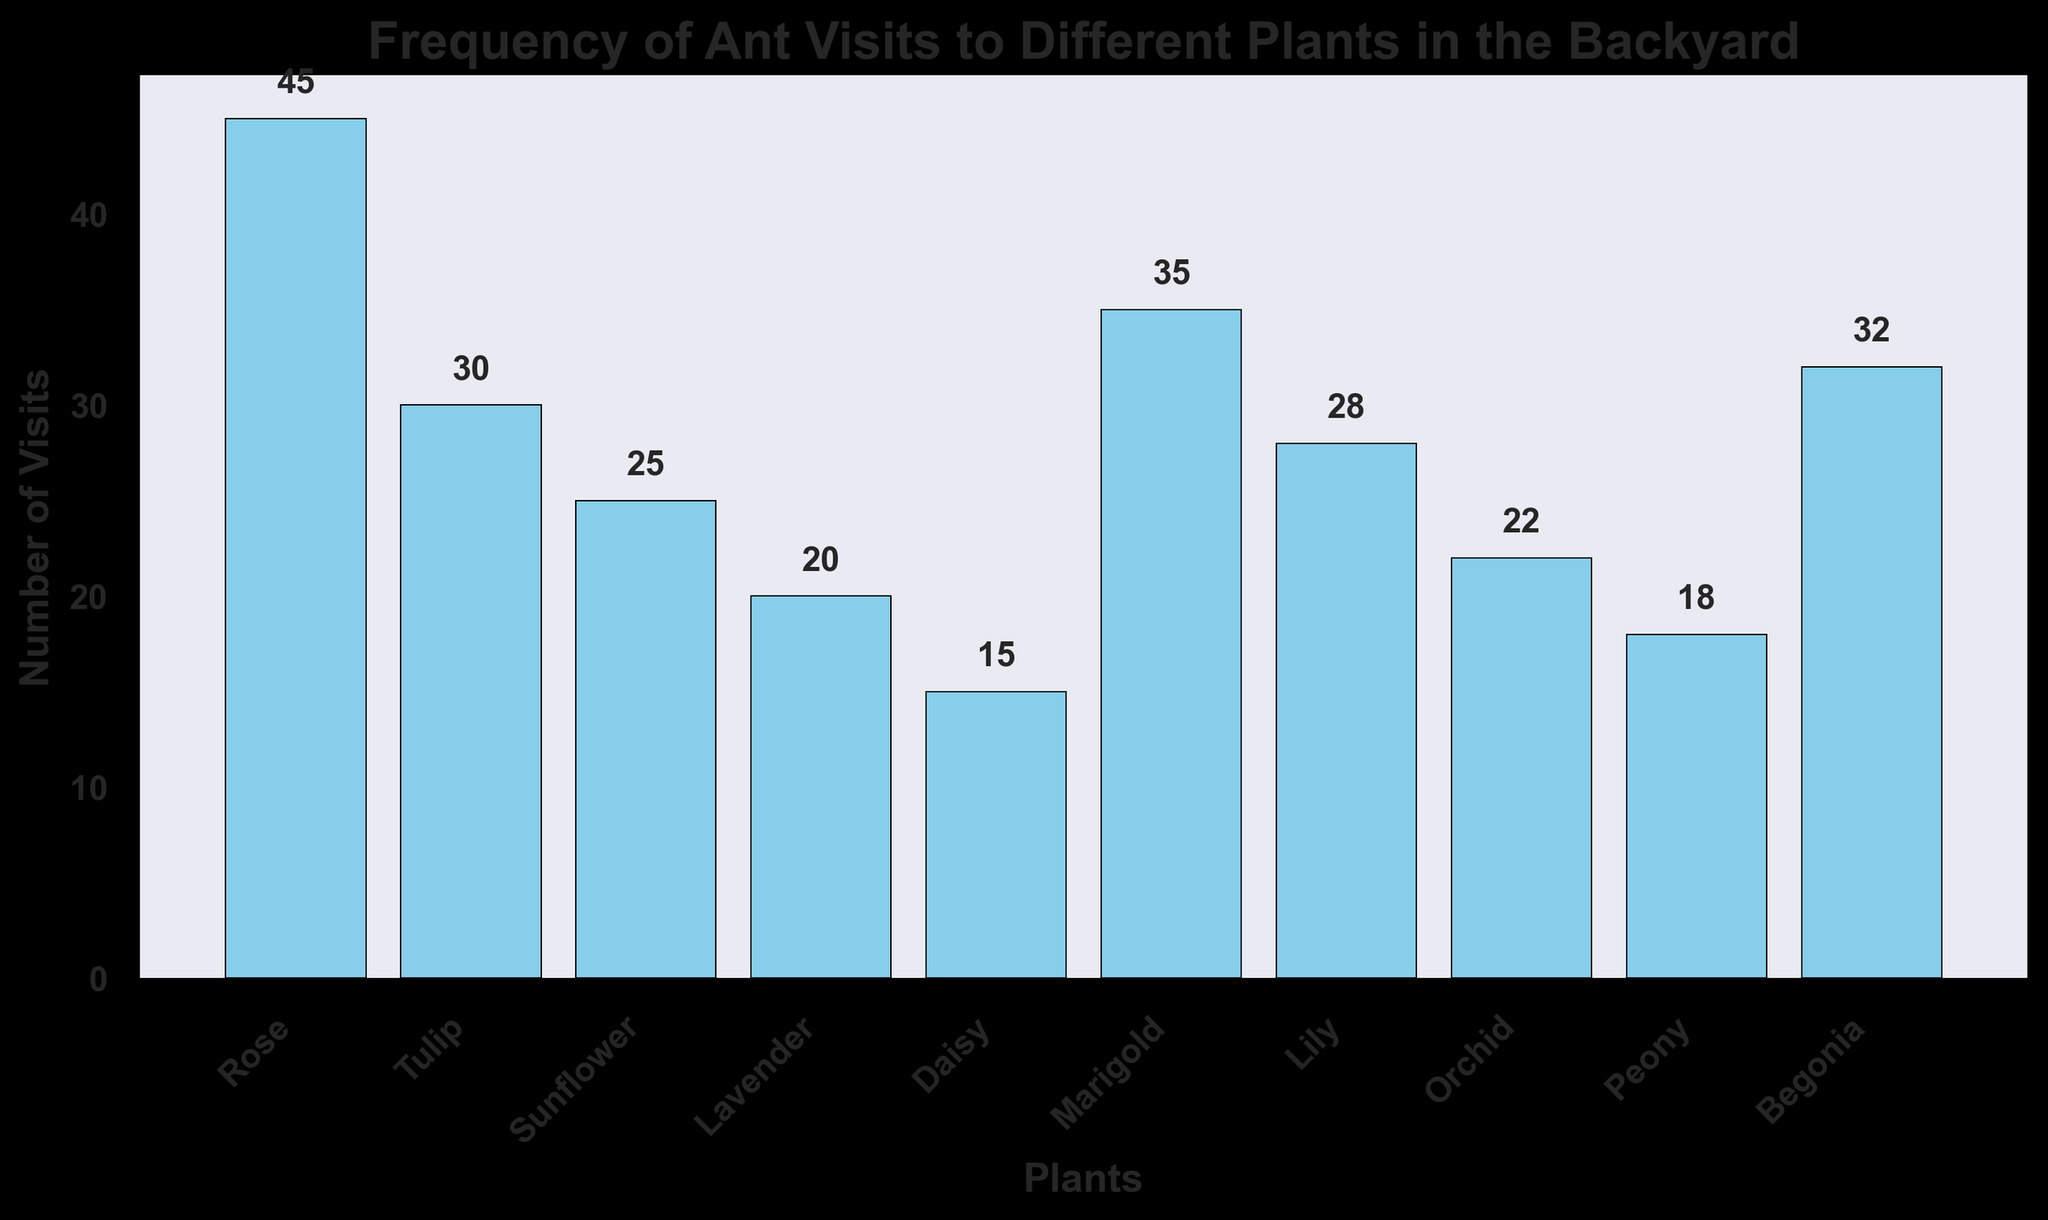Which plant had the highest number of ant visits? To determine this, look at the heights of the bars in the bar chart. The plant with the tallest bar represents the plant with the most visits. The Rose bar is the highest, indicating it had the most visits.
Answer: Rose Which two plants had the least number of ant visits? Look at the heights of the bars and find the two shortest ones. The Daisy bar, followed by the Lavender bar, are the shortest, thus these two plants had the fewest visits.
Answer: Daisy, Lavender What is the difference in the number of visits between the plant with the most visits and the plant with the least visits? First, identify the highest and lowest values from the bar chart. The most visits are 45 (Rose) and the least is 15 (Daisy). Subtract the smallest value from the largest: 45 - 15.
Answer: 30 What is the total number of ant visits to all the plants combined? Sum the numbers above the bars. 45 (Rose) + 30 (Tulip) + 25 (Sunflower) + 20 (Lavender) + 15 (Daisy) + 35 (Marigold) + 28 (Lily) + 22 (Orchid) + 18 (Peony) + 32 (Begonia) = 270.
Answer: 270 Which plant had more visits, Marigold or Lily, and by how much? Compare the heights of the Marigold and Lily bars. Marigold had 35 visits and Lily had 28. Subtract the smaller value from the larger: 35 - 28.
Answer: Marigold, 7 How many plants had more than 30 ant visits? Identify the bars taller than the one labeled 30. The Rose (45), Marigold (35), Tulip (30), and Begonia (32) bars are taller. Count them: 4 plants.
Answer: 4 What is the average number of visits per plant? Add all the visits and divide by the number of plants. The total number is 270, and there are 10 plants: 270 / 10.
Answer: 27 What is the median number of ant visits to the plants? List the number of visits in ascending order and find the middle value. If there are 10 values, take the average of the 5th and 6th values. The ordered list is 15, 18, 20, 22, 25, 28, 30, 32, 35, 45. (25+28)/2.
Answer: 26.5 Which plant had fewer visits, Orchid or Peony? Compare the heights of the Orchid and Peony bars. Orchid had 22 visits, and Peony had 18. Thus, Peony had fewer visits.
Answer: Peony 